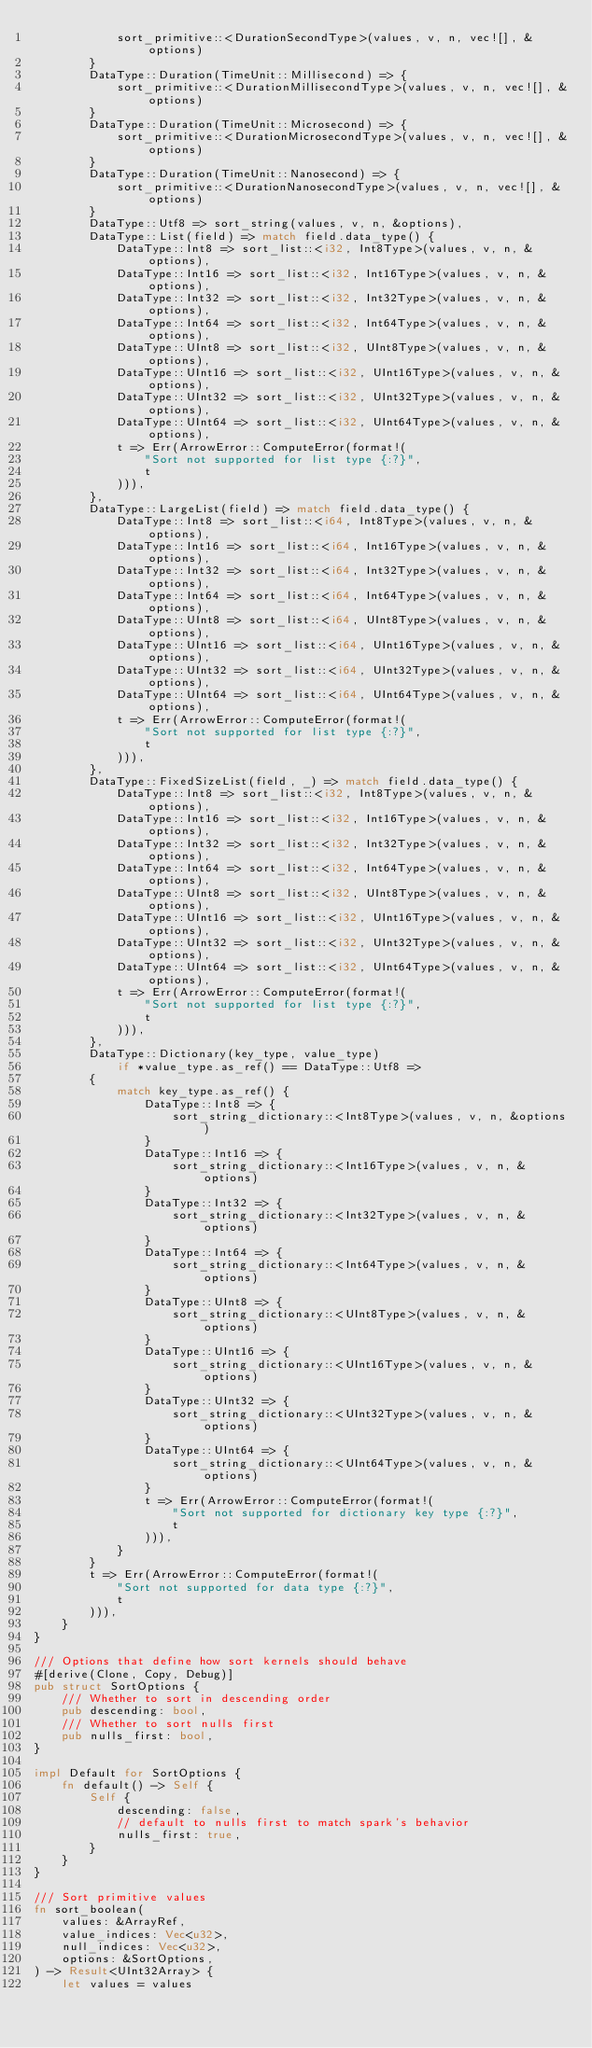<code> <loc_0><loc_0><loc_500><loc_500><_Rust_>            sort_primitive::<DurationSecondType>(values, v, n, vec![], &options)
        }
        DataType::Duration(TimeUnit::Millisecond) => {
            sort_primitive::<DurationMillisecondType>(values, v, n, vec![], &options)
        }
        DataType::Duration(TimeUnit::Microsecond) => {
            sort_primitive::<DurationMicrosecondType>(values, v, n, vec![], &options)
        }
        DataType::Duration(TimeUnit::Nanosecond) => {
            sort_primitive::<DurationNanosecondType>(values, v, n, vec![], &options)
        }
        DataType::Utf8 => sort_string(values, v, n, &options),
        DataType::List(field) => match field.data_type() {
            DataType::Int8 => sort_list::<i32, Int8Type>(values, v, n, &options),
            DataType::Int16 => sort_list::<i32, Int16Type>(values, v, n, &options),
            DataType::Int32 => sort_list::<i32, Int32Type>(values, v, n, &options),
            DataType::Int64 => sort_list::<i32, Int64Type>(values, v, n, &options),
            DataType::UInt8 => sort_list::<i32, UInt8Type>(values, v, n, &options),
            DataType::UInt16 => sort_list::<i32, UInt16Type>(values, v, n, &options),
            DataType::UInt32 => sort_list::<i32, UInt32Type>(values, v, n, &options),
            DataType::UInt64 => sort_list::<i32, UInt64Type>(values, v, n, &options),
            t => Err(ArrowError::ComputeError(format!(
                "Sort not supported for list type {:?}",
                t
            ))),
        },
        DataType::LargeList(field) => match field.data_type() {
            DataType::Int8 => sort_list::<i64, Int8Type>(values, v, n, &options),
            DataType::Int16 => sort_list::<i64, Int16Type>(values, v, n, &options),
            DataType::Int32 => sort_list::<i64, Int32Type>(values, v, n, &options),
            DataType::Int64 => sort_list::<i64, Int64Type>(values, v, n, &options),
            DataType::UInt8 => sort_list::<i64, UInt8Type>(values, v, n, &options),
            DataType::UInt16 => sort_list::<i64, UInt16Type>(values, v, n, &options),
            DataType::UInt32 => sort_list::<i64, UInt32Type>(values, v, n, &options),
            DataType::UInt64 => sort_list::<i64, UInt64Type>(values, v, n, &options),
            t => Err(ArrowError::ComputeError(format!(
                "Sort not supported for list type {:?}",
                t
            ))),
        },
        DataType::FixedSizeList(field, _) => match field.data_type() {
            DataType::Int8 => sort_list::<i32, Int8Type>(values, v, n, &options),
            DataType::Int16 => sort_list::<i32, Int16Type>(values, v, n, &options),
            DataType::Int32 => sort_list::<i32, Int32Type>(values, v, n, &options),
            DataType::Int64 => sort_list::<i32, Int64Type>(values, v, n, &options),
            DataType::UInt8 => sort_list::<i32, UInt8Type>(values, v, n, &options),
            DataType::UInt16 => sort_list::<i32, UInt16Type>(values, v, n, &options),
            DataType::UInt32 => sort_list::<i32, UInt32Type>(values, v, n, &options),
            DataType::UInt64 => sort_list::<i32, UInt64Type>(values, v, n, &options),
            t => Err(ArrowError::ComputeError(format!(
                "Sort not supported for list type {:?}",
                t
            ))),
        },
        DataType::Dictionary(key_type, value_type)
            if *value_type.as_ref() == DataType::Utf8 =>
        {
            match key_type.as_ref() {
                DataType::Int8 => {
                    sort_string_dictionary::<Int8Type>(values, v, n, &options)
                }
                DataType::Int16 => {
                    sort_string_dictionary::<Int16Type>(values, v, n, &options)
                }
                DataType::Int32 => {
                    sort_string_dictionary::<Int32Type>(values, v, n, &options)
                }
                DataType::Int64 => {
                    sort_string_dictionary::<Int64Type>(values, v, n, &options)
                }
                DataType::UInt8 => {
                    sort_string_dictionary::<UInt8Type>(values, v, n, &options)
                }
                DataType::UInt16 => {
                    sort_string_dictionary::<UInt16Type>(values, v, n, &options)
                }
                DataType::UInt32 => {
                    sort_string_dictionary::<UInt32Type>(values, v, n, &options)
                }
                DataType::UInt64 => {
                    sort_string_dictionary::<UInt64Type>(values, v, n, &options)
                }
                t => Err(ArrowError::ComputeError(format!(
                    "Sort not supported for dictionary key type {:?}",
                    t
                ))),
            }
        }
        t => Err(ArrowError::ComputeError(format!(
            "Sort not supported for data type {:?}",
            t
        ))),
    }
}

/// Options that define how sort kernels should behave
#[derive(Clone, Copy, Debug)]
pub struct SortOptions {
    /// Whether to sort in descending order
    pub descending: bool,
    /// Whether to sort nulls first
    pub nulls_first: bool,
}

impl Default for SortOptions {
    fn default() -> Self {
        Self {
            descending: false,
            // default to nulls first to match spark's behavior
            nulls_first: true,
        }
    }
}

/// Sort primitive values
fn sort_boolean(
    values: &ArrayRef,
    value_indices: Vec<u32>,
    null_indices: Vec<u32>,
    options: &SortOptions,
) -> Result<UInt32Array> {
    let values = values</code> 